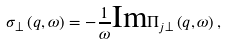Convert formula to latex. <formula><loc_0><loc_0><loc_500><loc_500>\sigma _ { \perp } \left ( q , \omega \right ) = - \frac { 1 } { \omega } \text {Im} \Pi _ { j \bot } \left ( q , \omega \right ) ,</formula> 